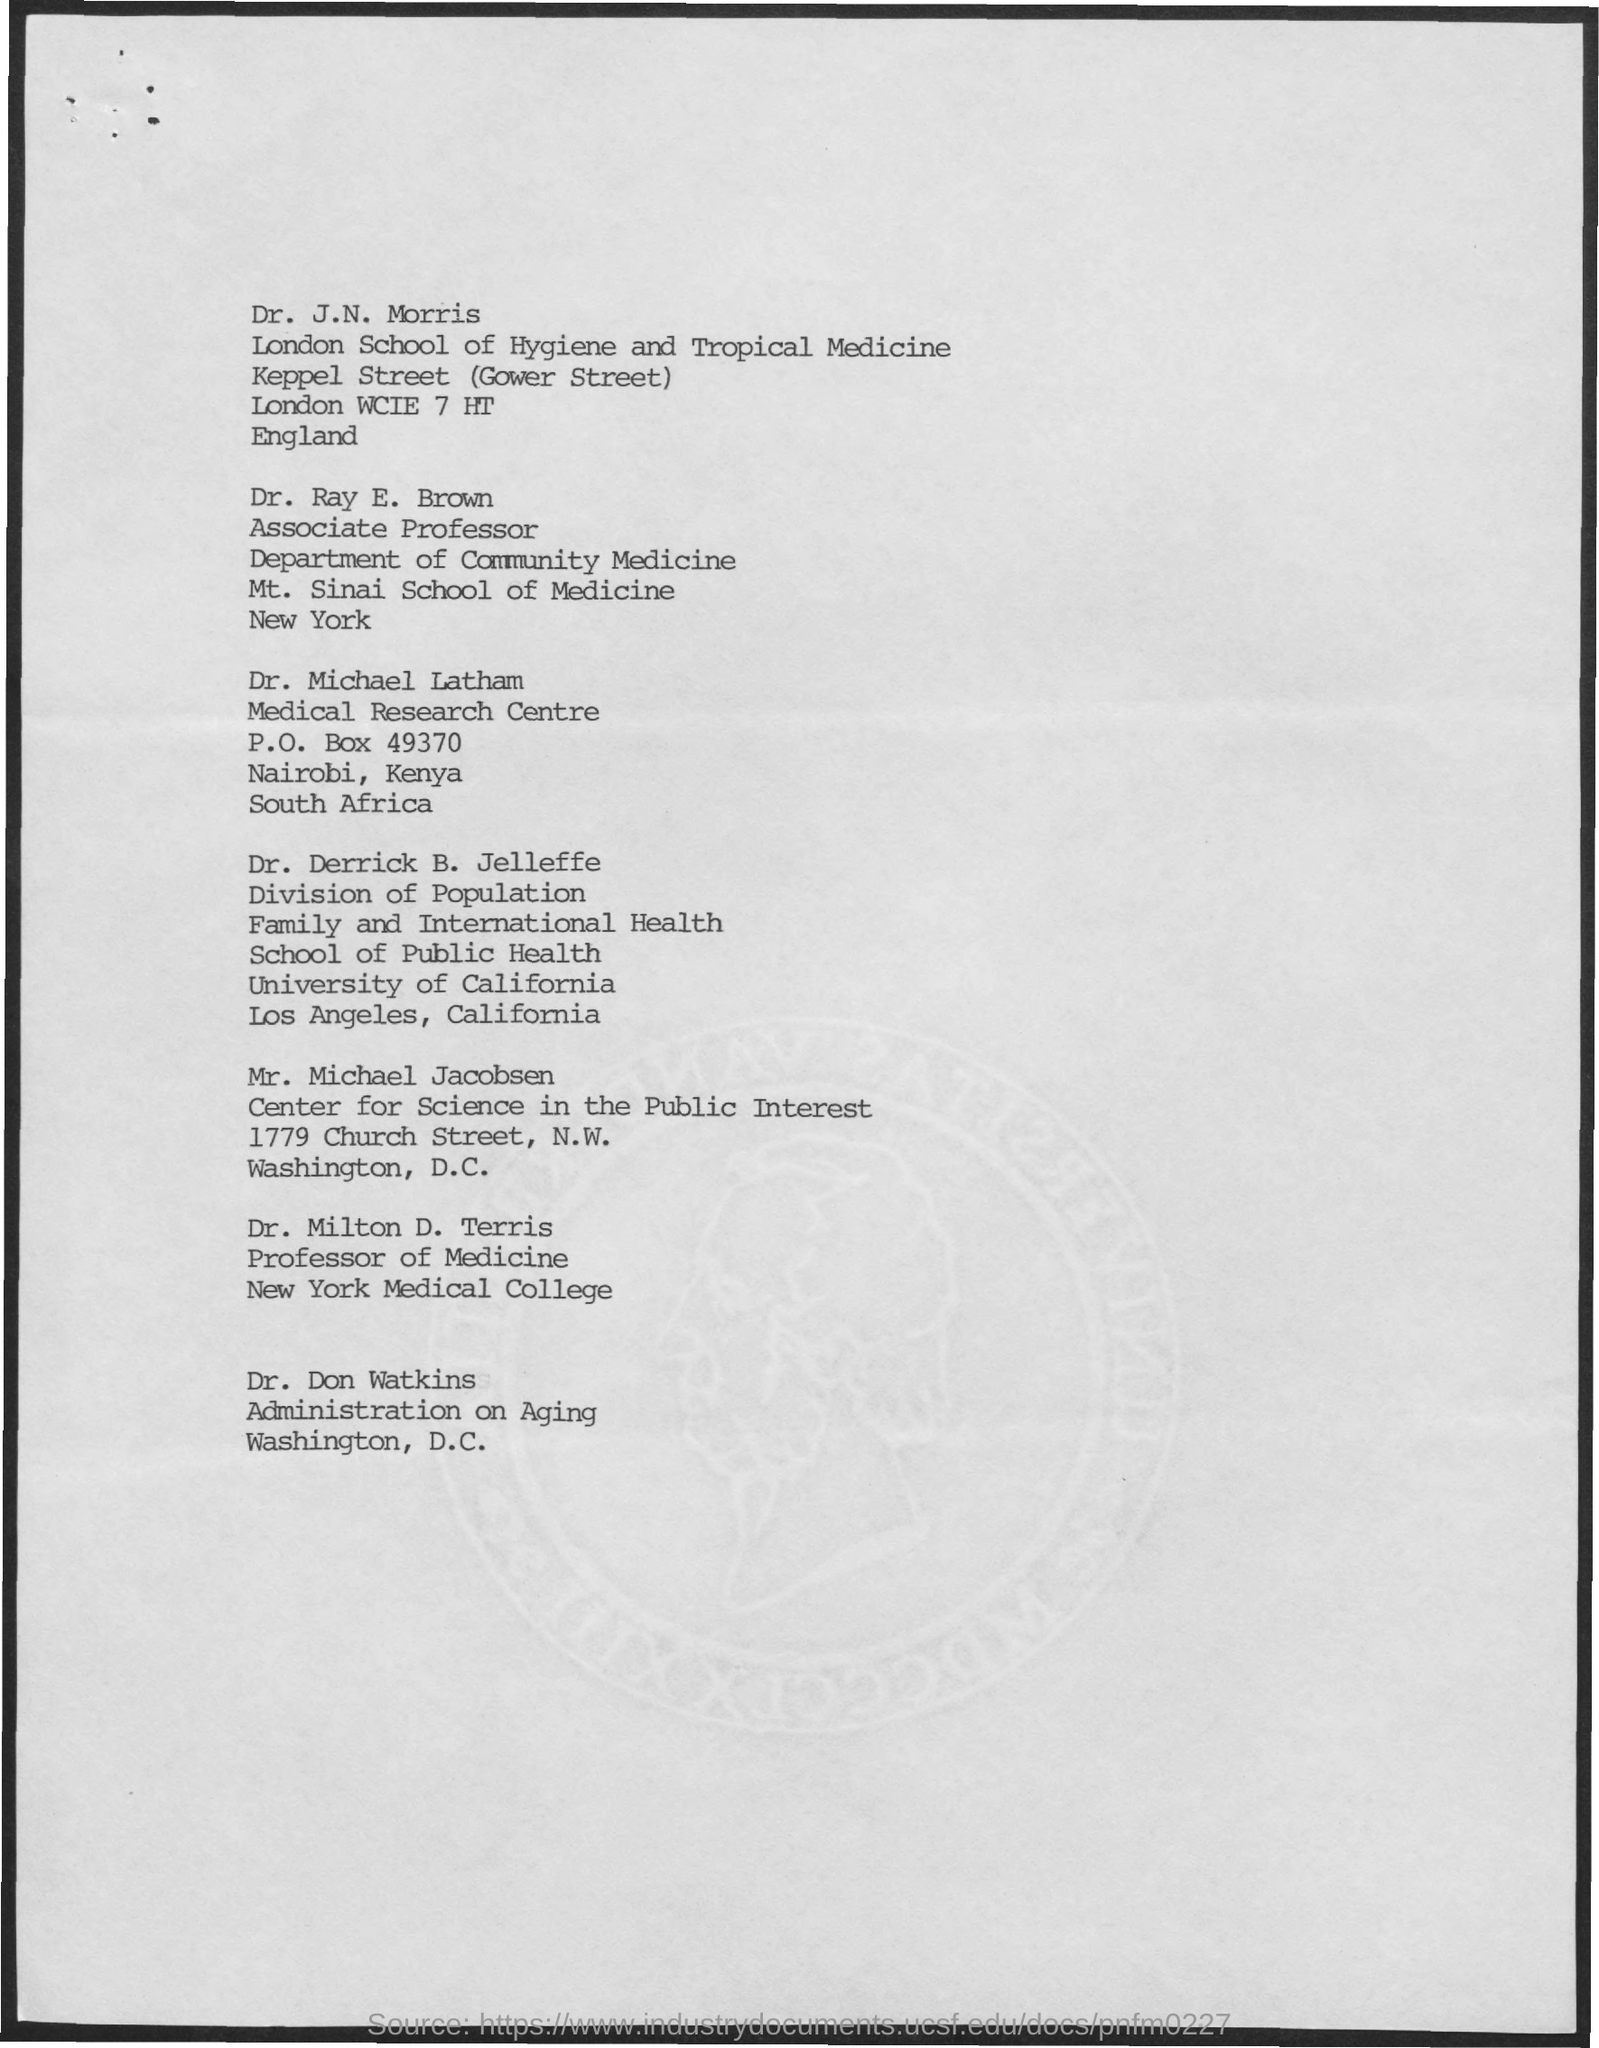What is the designation of dr. ray e. brown ?
Offer a very short reply. Associate professor. To which department dr. ray e. brown belongs to ?
Provide a succinct answer. Department of community medicine. 